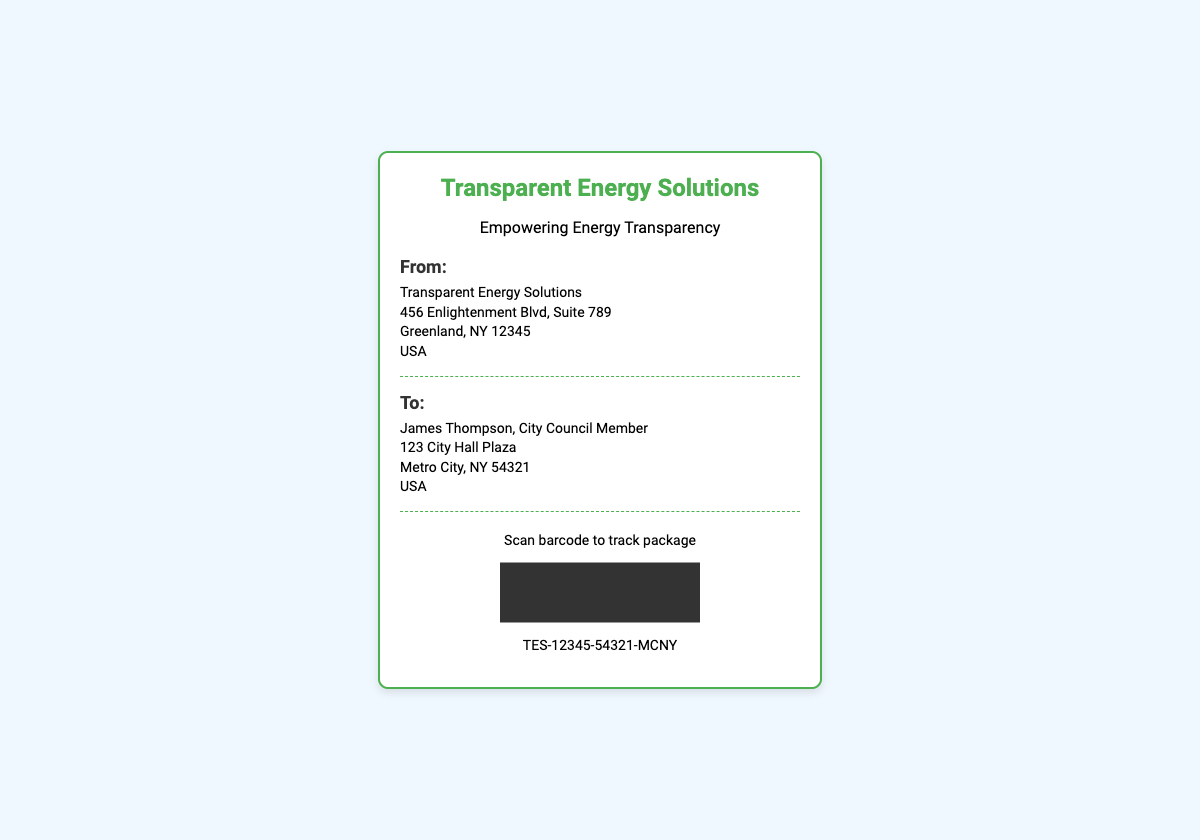What is the name of the company? The name of the company is displayed prominently at the top of the shipping label.
Answer: Transparent Energy Solutions Where is the shipping label being sent from? The address of the sender is listed in the "From" section of the document.
Answer: 456 Enlightenment Blvd, Suite 789, Greenland, NY 12345, USA Who is the recipient of the package? The recipient's name is mentioned in the "To" section of the label.
Answer: James Thompson What is the tracking code for the package? The tracking code is indicated below the barcode on the label.
Answer: TES-12345-54321-MCNY What is the purpose of the shipping? The purpose is indicated by the tagline under the company's name.
Answer: Empowering Energy Transparency What type of document is this? The overall layout and information displayed suggest the nature of the document.
Answer: Shipping label How many dividers are present on the shipping label? Each section is separated by a visible divider, and counting them gives the total number.
Answer: 2 What city is the recipient located in? The city is part of the recipient's address provided in the "To" section.
Answer: Metro City What color is used for the company logo? The primary color of the logo can be identified from its appearance on the label.
Answer: Green 